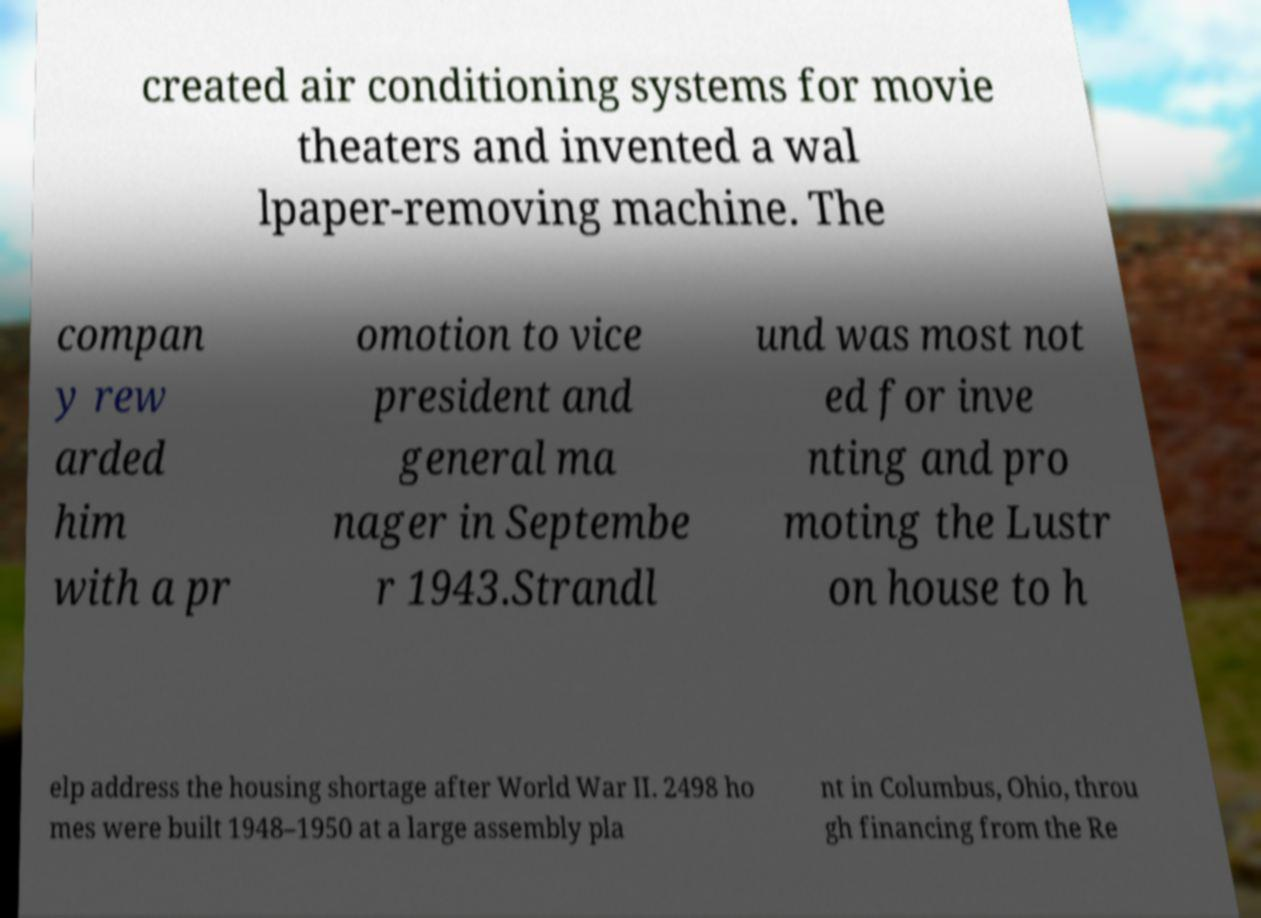Could you extract and type out the text from this image? created air conditioning systems for movie theaters and invented a wal lpaper-removing machine. The compan y rew arded him with a pr omotion to vice president and general ma nager in Septembe r 1943.Strandl und was most not ed for inve nting and pro moting the Lustr on house to h elp address the housing shortage after World War II. 2498 ho mes were built 1948–1950 at a large assembly pla nt in Columbus, Ohio, throu gh financing from the Re 